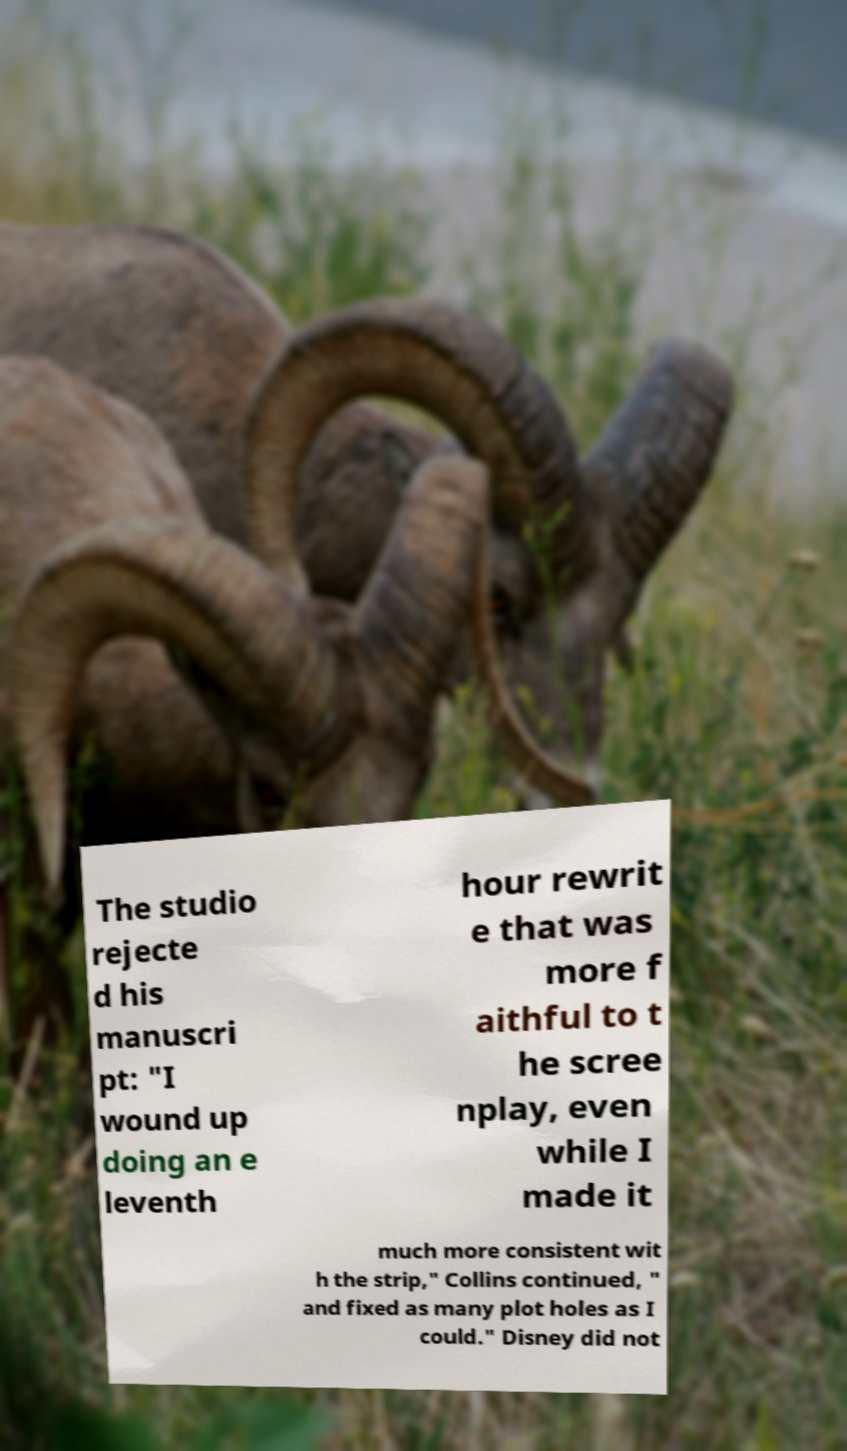Can you read and provide the text displayed in the image?This photo seems to have some interesting text. Can you extract and type it out for me? The studio rejecte d his manuscri pt: "I wound up doing an e leventh hour rewrit e that was more f aithful to t he scree nplay, even while I made it much more consistent wit h the strip," Collins continued, " and fixed as many plot holes as I could." Disney did not 